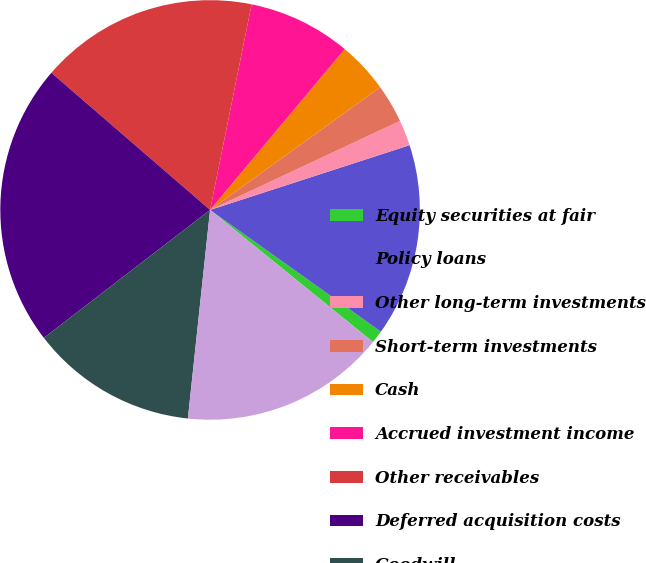Convert chart. <chart><loc_0><loc_0><loc_500><loc_500><pie_chart><fcel>Equity securities at fair<fcel>Policy loans<fcel>Other long-term investments<fcel>Short-term investments<fcel>Cash<fcel>Accrued investment income<fcel>Other receivables<fcel>Deferred acquisition costs<fcel>Goodwill<fcel>Other assets<nl><fcel>0.99%<fcel>14.85%<fcel>1.98%<fcel>2.97%<fcel>3.96%<fcel>7.92%<fcel>16.83%<fcel>21.78%<fcel>12.87%<fcel>15.84%<nl></chart> 